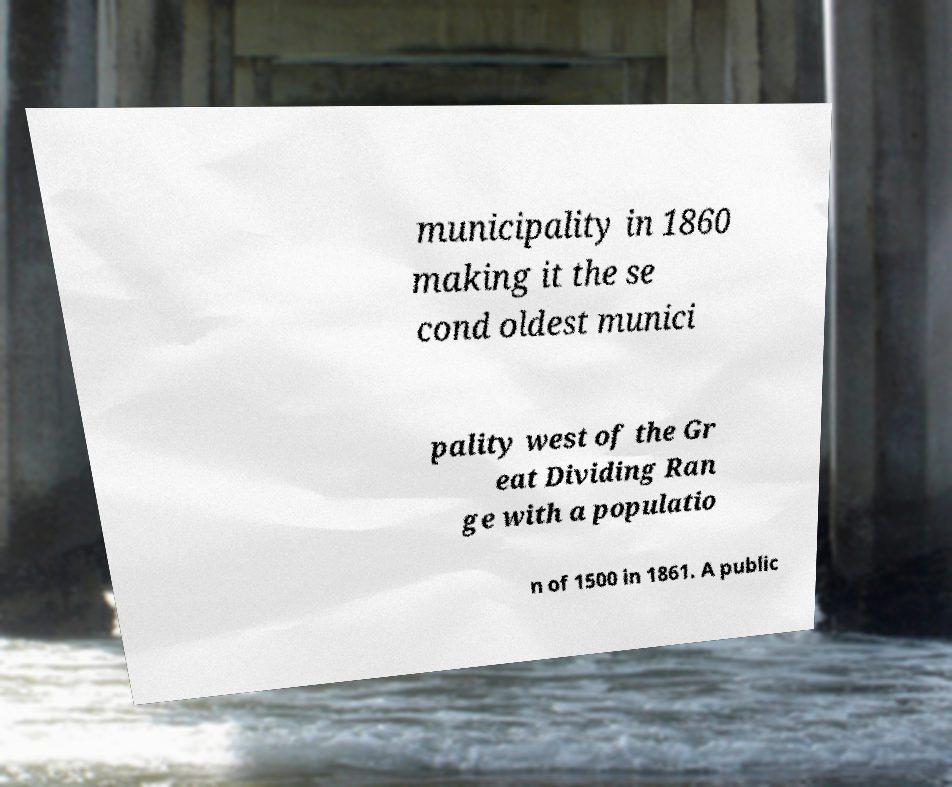Could you assist in decoding the text presented in this image and type it out clearly? municipality in 1860 making it the se cond oldest munici pality west of the Gr eat Dividing Ran ge with a populatio n of 1500 in 1861. A public 